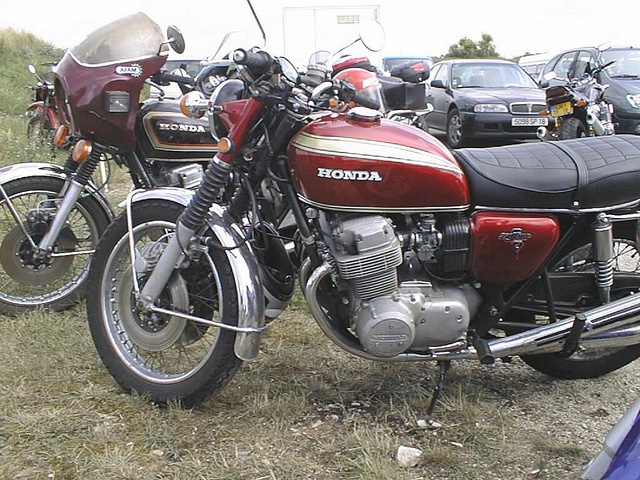Describe the objects in this image and their specific colors. I can see motorcycle in white, black, gray, darkgray, and lightgray tones, motorcycle in white, gray, black, darkgray, and lightgray tones, car in white, lavender, gray, black, and darkgray tones, car in white, lavender, darkgray, and gray tones, and motorcycle in white, gray, lightgray, black, and darkgray tones in this image. 